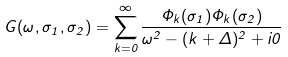Convert formula to latex. <formula><loc_0><loc_0><loc_500><loc_500>G ( \omega , \sigma _ { 1 } , \sigma _ { 2 } ) = \sum _ { k = 0 } ^ { \infty } \frac { \Phi _ { k } ( \sigma _ { 1 } ) \Phi _ { k } ( \sigma _ { 2 } ) } { \omega ^ { 2 } - ( k + \Delta ) ^ { 2 } + i 0 }</formula> 